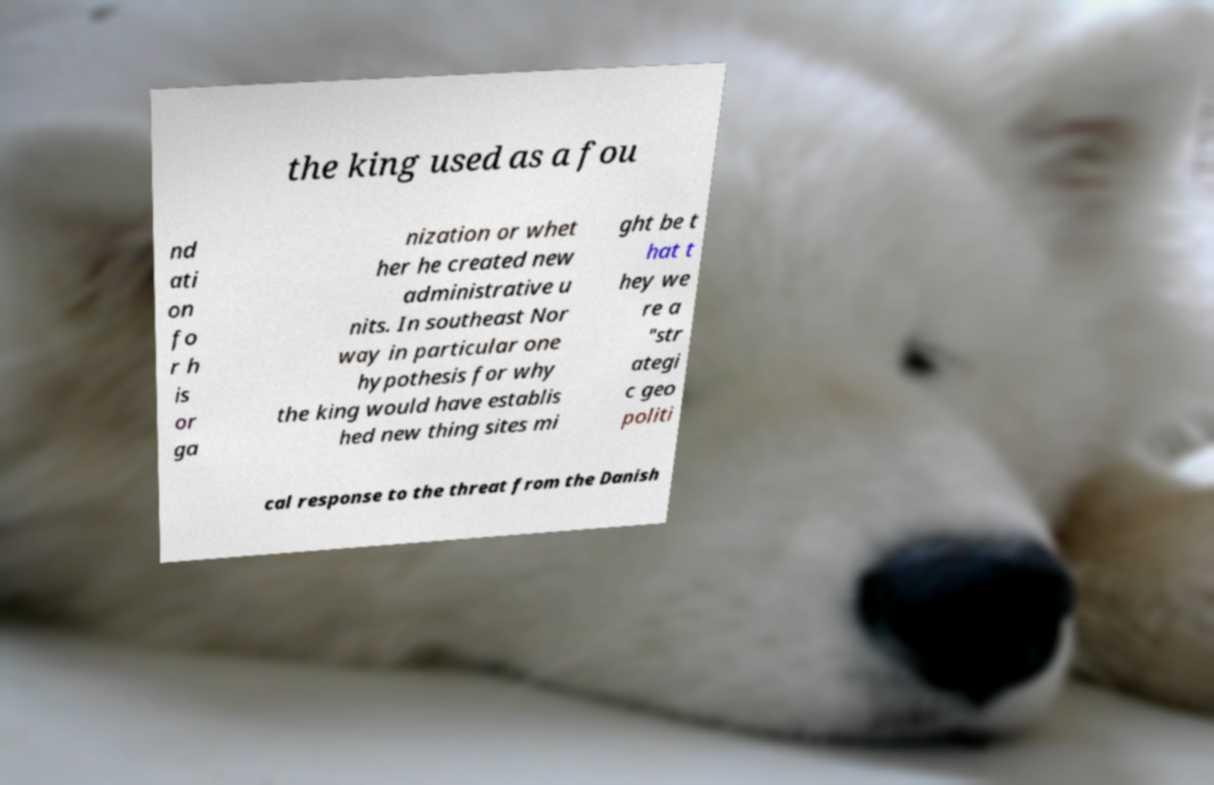Please read and relay the text visible in this image. What does it say? the king used as a fou nd ati on fo r h is or ga nization or whet her he created new administrative u nits. In southeast Nor way in particular one hypothesis for why the king would have establis hed new thing sites mi ght be t hat t hey we re a "str ategi c geo politi cal response to the threat from the Danish 